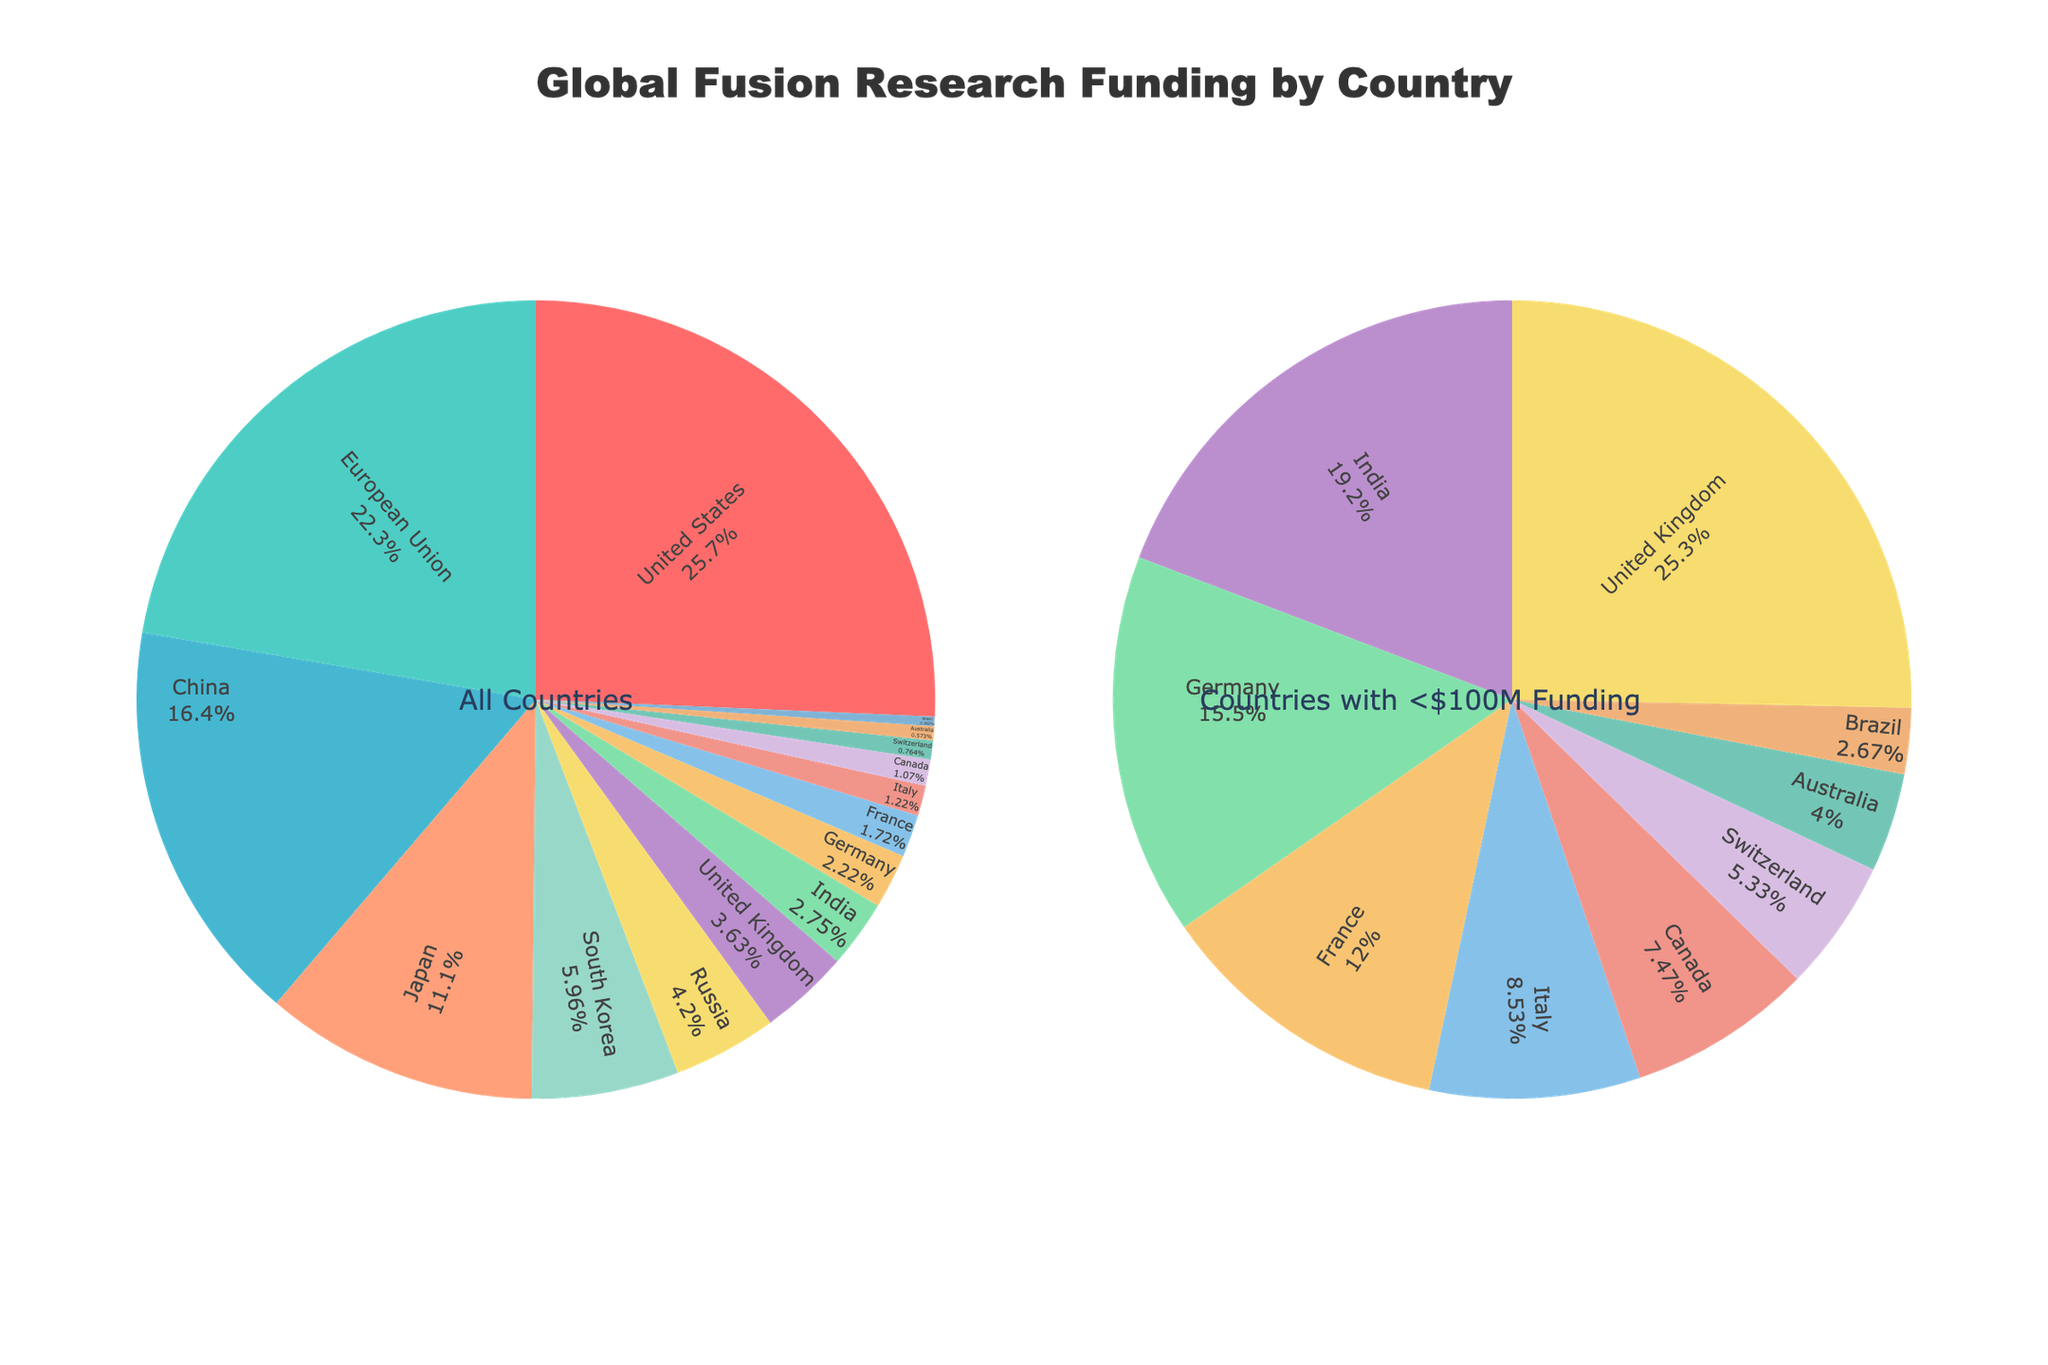What's the country with the highest funding in fusion research? The country with the highest funding in fusion research can be identified by looking at the slice with the largest area on the pie chart. The United States has the largest slice, indicating it has the highest funding.
Answer: United States Which countries have less than $100 million in fusion research funding? In the second pie chart titled "Countries with <$100M Funding", all the countries listed have less than $100 million in funding. These include Russia, United Kingdom, India, Germany, France, Italy, Canada, Switzerland, Australia, and Brazil.
Answer: Russia, United Kingdom, India, Germany, France, Italy, Canada, Switzerland, Australia, Brazil What percentage of global fusion research funding is provided by the top three countries? The top three countries by funding are United States, European Union, and China. By examining the percentages on the main pie chart, we sum their percentages. Assuming the pie chart is scaled properly, United States has around 29%, European Union has around 25%, and China has approximately 18%. Therefore, the total percentage is 29% + 25% + 18% = 72%.
Answer: 72% By how much does the funding of Japan differ from that of South Korea? From the figure, Japan's funding is $290 million while South Korea's is $156 million. The difference in their funding is calculated as $290 million - $156 million = $134 million.
Answer: $134 million Which has a larger share in fusion research funding, Germany or France? To determine which country has a larger share, we compare the slice sizes in the second pie chart. Germany's share is larger than France’s as indicated by the size of their respective slices.
Answer: Germany What is the combined funding of countries with less than $100 million? The second pie chart provides the funding for countries with less than $100 million: Russia ($110M), United Kingdom ($95M), India ($72M), Germany ($58M), France ($45M), Italy ($32M), Canada ($28M), Switzerland ($20M), Australia ($15M), Brazil ($10M). Summing these totals: $110M + $95M + $72M + $58M + $45M + $32M + $28M + $20M + $15M + $10M = $485M.
Answer: $485 million What fraction of the total funding does the European Union contribute? First, observe that the European Union has $584 million in funding. The total global funding is the sum of all the individual funding amounts: $672M (USA) + $584M (EU) + $430M (China) + $290M (Japan) + $156M (South Korea) + $110M (Russia) + $95M (UK) + $72M (India) + $58M (Germany) + $45M (France) + $32M (Italy) + $28M (Canada) + $20M (Switzerland) + $15M (Australia) + $10M (Brazil) = $2,617M. The fraction contributed by the EU is $584M / $2,617M ≈ 22.3%.
Answer: 22.3% Compare the funding of the United Kingdom and India. Which country has higher funding and by how much? From the second pie chart, the United Kingdom has $95 million in funding while India has $72 million. To find the difference, subtract India's funding from the United Kingdom's: $95 million - $72 million = $23 million.
Answer: United Kingdom by $23 million How much more does the United States invest in fusion research compared to China? The main pie chart shows that the United States invests $672 million while China invests $430 million. The difference is calculated by subtracting China's investment from that of the United States: $672 million - $430 million = $242 million.
Answer: $242 million 